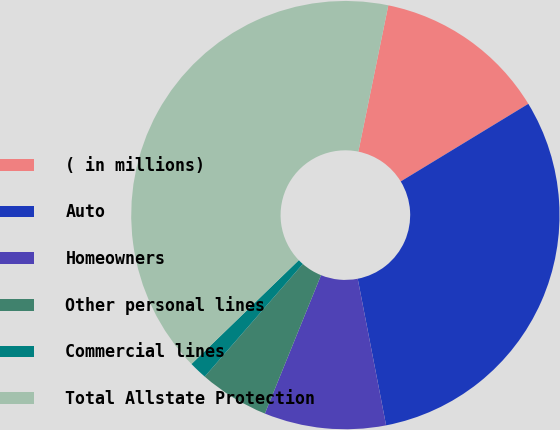Convert chart to OTSL. <chart><loc_0><loc_0><loc_500><loc_500><pie_chart><fcel>( in millions)<fcel>Auto<fcel>Homeowners<fcel>Other personal lines<fcel>Commercial lines<fcel>Total Allstate Protection<nl><fcel>13.09%<fcel>30.65%<fcel>9.18%<fcel>5.27%<fcel>1.36%<fcel>40.45%<nl></chart> 